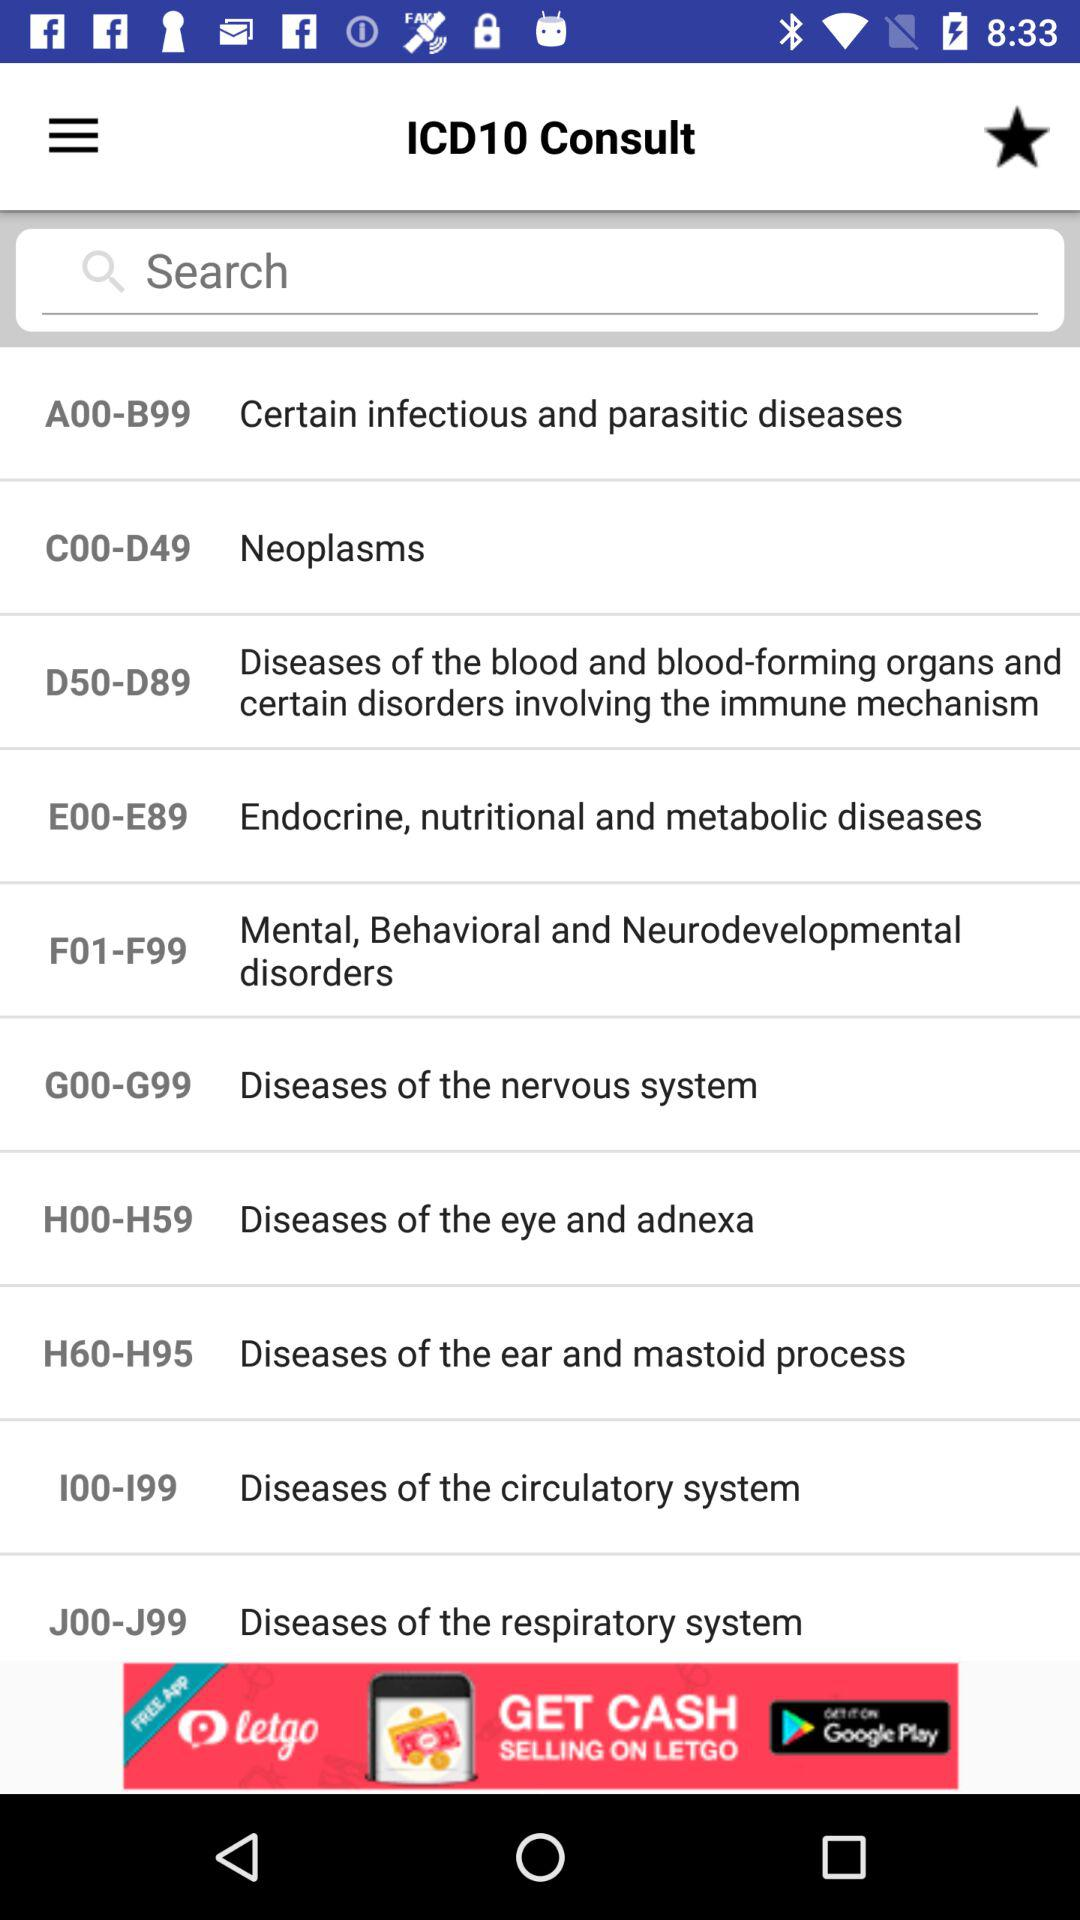What is the code for "Mental, Behavioral and Neurodevelopmental disorders"? The code is F01-F99. 